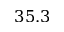<formula> <loc_0><loc_0><loc_500><loc_500>3 5 . 3</formula> 